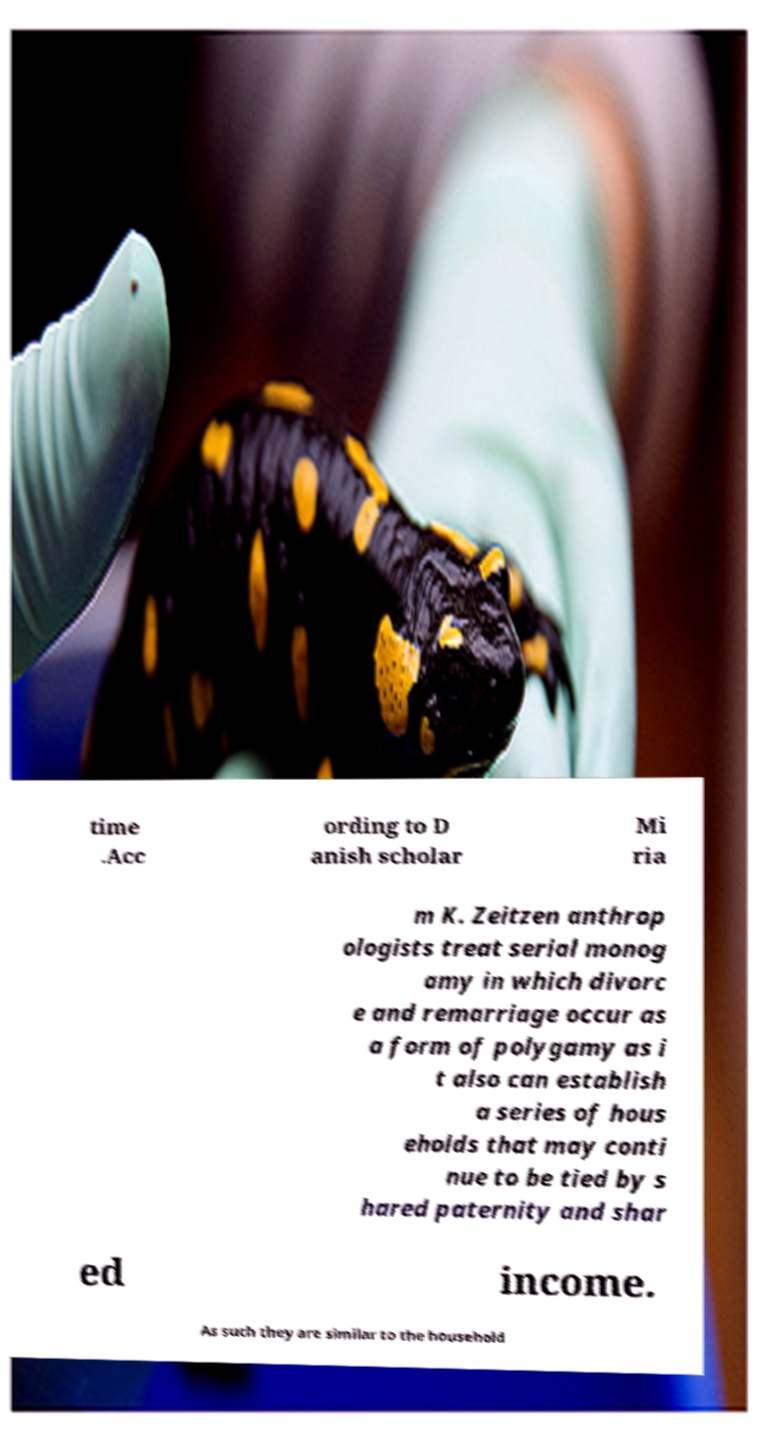Can you accurately transcribe the text from the provided image for me? time .Acc ording to D anish scholar Mi ria m K. Zeitzen anthrop ologists treat serial monog amy in which divorc e and remarriage occur as a form of polygamy as i t also can establish a series of hous eholds that may conti nue to be tied by s hared paternity and shar ed income. As such they are similar to the household 